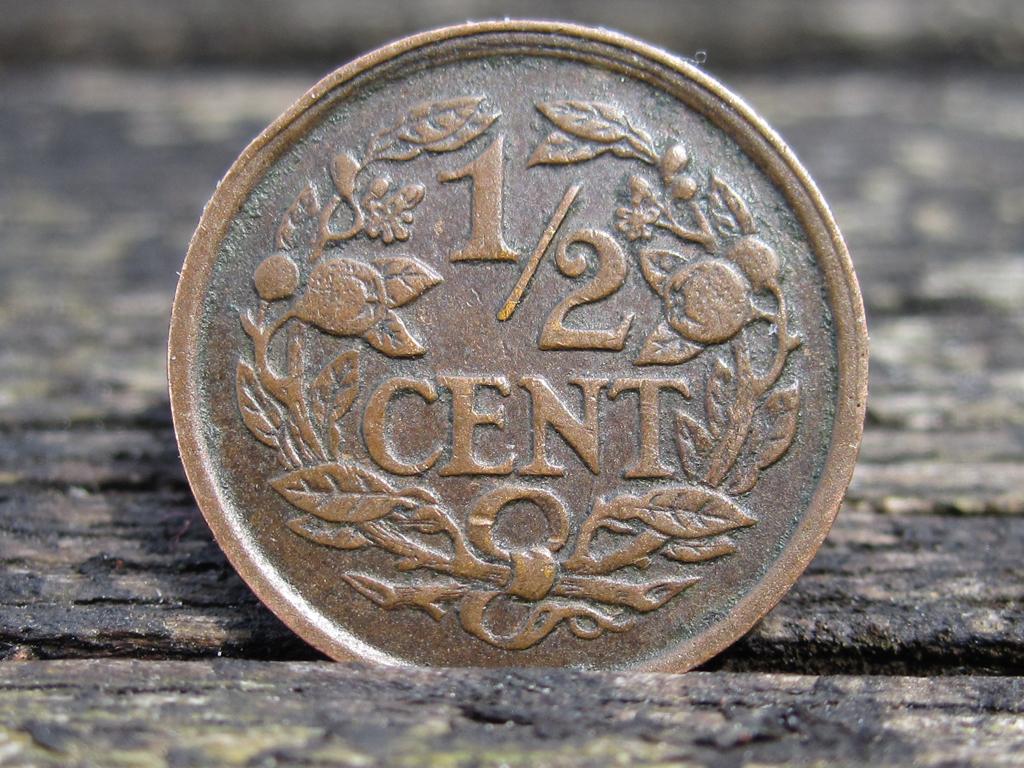How many cents is this?
Your answer should be compact. 1/2. This american dollar?
Your response must be concise. No. 